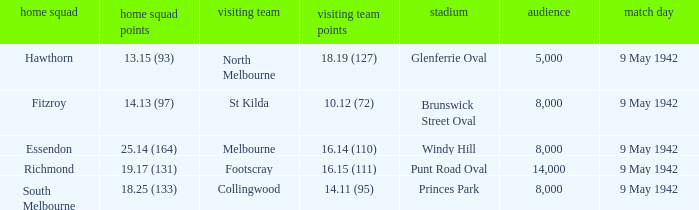How many people attended the game where Footscray was away? 14000.0. 